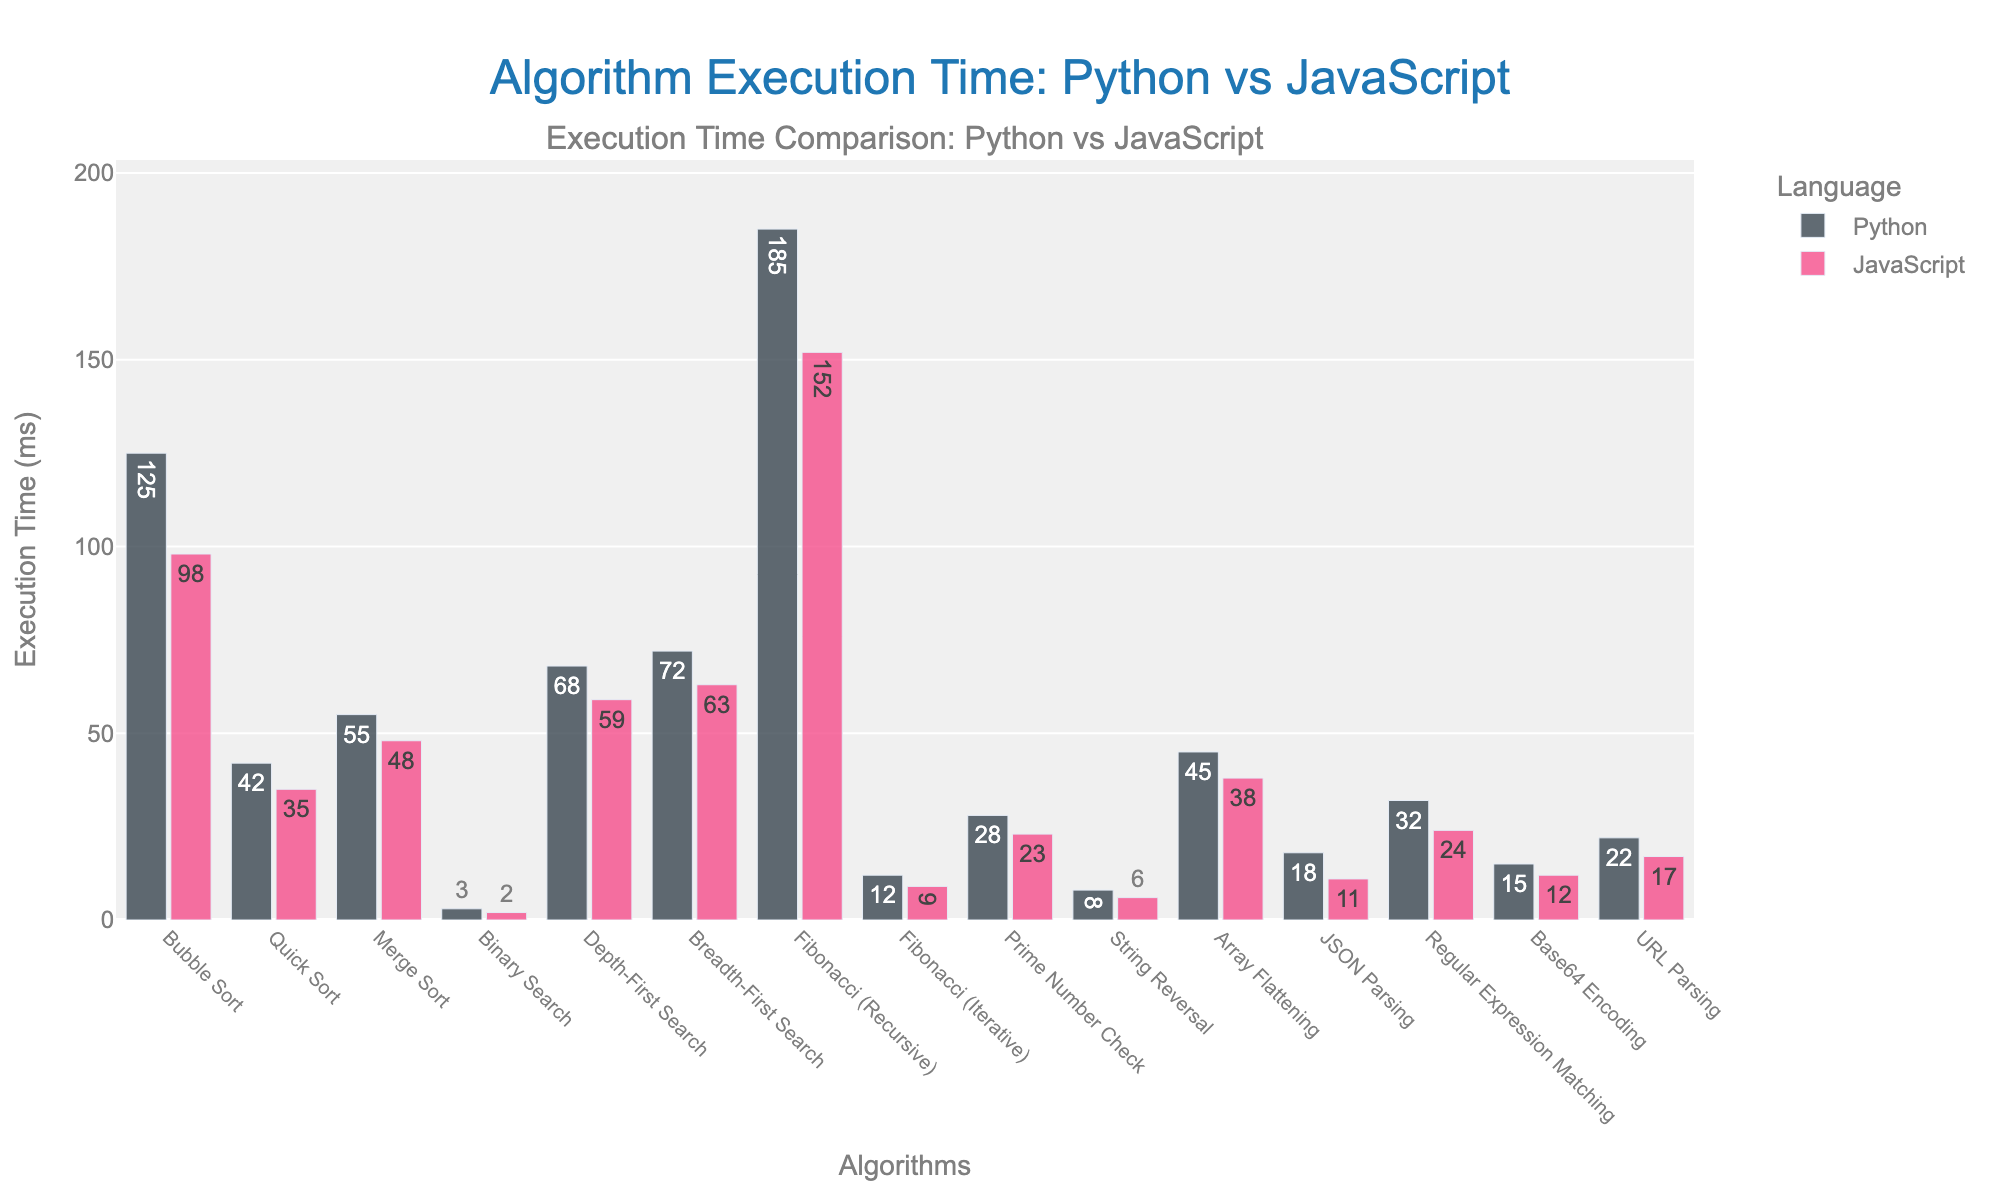What's the algorithm with the longest execution time in Python? The bar that represents Fibonacci (Recursive) in the Python section is visually the highest among all the Python bars.
Answer: Fibonacci (Recursive) Which algorithm shows the smallest difference in execution time between Python and JavaScript? Binary Search shows the smallest difference in execution time because the bar heights are very close. The respective times are 3 ms for Python and 2 ms for JavaScript, leading to a difference of only 1 ms.
Answer: Binary Search Which algorithm has a greater execution time in Python than in JavaScript? By comparing the heights of the bars for each algorithm between Python and JavaScript, all algorithms have higher execution times in Python than in JavaScript. For example, for Bubble Sort, Python's bar is taller than JavaScript's.
Answer: All algorithms What's the total execution time for JSON Parsing, Prime Number Check, and URL Parsing in JavaScript? Summing up the execution times of JSON Parsing (11 ms), Prime Number Check (23 ms), and URL Parsing (17 ms) in JavaScript gives a total. Calculation: 11 + 23 + 17 = 51 ms.
Answer: 51 ms How does the execution time for Bubble Sort in JavaScript compare to Fibonacci (Iterative) in Python? Comparing the heights of the bars, Bubble Sort in JavaScript takes 98 ms while Fibonacci (Iterative) in Python takes 12 ms. Therefore, Bubble Sort in JavaScript takes significantly more time.
Answer: Bubble Sort in JavaScript takes significantly more time What is the combined execution time for Depth-First Search and Breadth-First Search in Python? Add the execution times of Depth-First Search (68 ms) and Breadth-First Search (72 ms) in Python. Calculation: 68 + 72 = 140 ms.
Answer: 140 ms Which algorithm has the closest execution times between Python and JavaScript, and what are those times? Binary Search has execution times very close between Python (3 ms) and JavaScript (2 ms).
Answer: Binary Search, 3 ms in Python and 2 ms in JavaScript Compare the execution times of Merge Sort and Quick Sort in JavaScript. Which one is faster and by how much? Compare the heights of the bars for Merge Sort (48 ms) and Quick Sort (35 ms) in JavaScript. Quick Sort is faster by 48 - 35 = 13 ms.
Answer: Quick Sort is faster by 13 ms Which algorithm has the highest difference in execution time between Python and JavaScript? Fibonacci (Recursive) has the highest difference in execution time. Python takes 185 ms and JavaScript takes 152 ms. The difference is 185 - 152 = 33 ms.
Answer: Fibonacci (Recursive) What is the average execution time of all algorithms in JavaScript? Sum all the execution times for the algorithms in JavaScript and then divide by the number of algorithms. Totals for JavaScript times are: 98 + 35 + 48 + 2 + 59 + 63 + 152 + 9 + 23 + 6 + 38 + 11 + 24 + 12 + 17 = 597, and there are 15 algorithms. Calculation: 597 / 15 = 39.8 ms.
Answer: 39.8 ms 